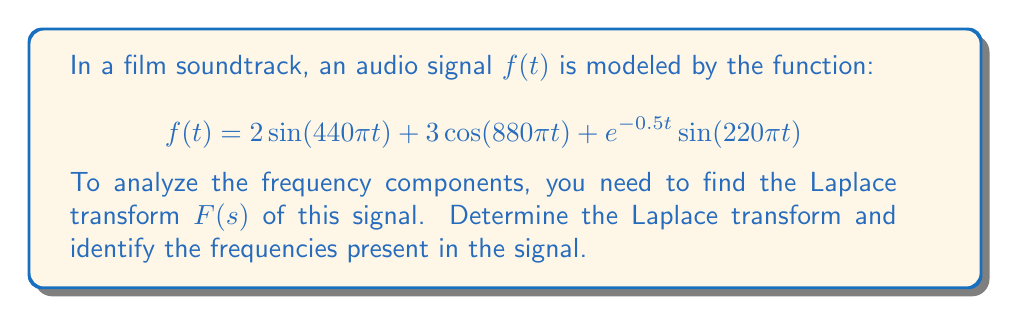Show me your answer to this math problem. To solve this problem, we'll use the Laplace transform properties and the linearity property to break down the function into simpler components.

1) First, recall the Laplace transforms of sine and cosine functions:
   $$\mathcal{L}\{\sin(\omega t)\} = \frac{\omega}{s^2 + \omega^2}$$
   $$\mathcal{L}\{\cos(\omega t)\} = \frac{s}{s^2 + \omega^2}$$

2) For the term $e^{-0.5t}\sin(220\pi t)$, we'll use the frequency shift property:
   $$\mathcal{L}\{e^{at}f(t)\} = F(s-a)$$

3) Now, let's transform each term:

   a) $2\sin(440\pi t)$:
      $$2 \cdot \frac{440\pi}{s^2 + (440\pi)^2} = \frac{880\pi}{s^2 + (440\pi)^2}$$

   b) $3\cos(880\pi t)$:
      $$3 \cdot \frac{s}{s^2 + (880\pi)^2} = \frac{3s}{s^2 + (880\pi)^2}$$

   c) $e^{-0.5t}\sin(220\pi t)$:
      $$\frac{220\pi}{(s+0.5)^2 + (220\pi)^2}$$

4) Using the linearity property of Laplace transforms, we sum these components:

   $$F(s) = \frac{880\pi}{s^2 + (440\pi)^2} + \frac{3s}{s^2 + (880\pi)^2} + \frac{220\pi}{(s+0.5)^2 + (220\pi)^2}$$

5) To identify the frequencies, we look at the denominators of each term:
   - $440\pi$ rad/s ≈ 220 Hz
   - $880\pi$ rad/s ≈ 440 Hz
   - $220\pi$ rad/s ≈ 110 Hz

These frequencies correspond to musical notes: A3 (220 Hz), A4 (440 Hz), and A2 (110 Hz).
Answer: The Laplace transform of the signal is:

$$F(s) = \frac{880\pi}{s^2 + (440\pi)^2} + \frac{3s}{s^2 + (880\pi)^2} + \frac{220\pi}{(s+0.5)^2 + (220\pi)^2}$$

The frequencies present in the signal are approximately 110 Hz, 220 Hz, and 440 Hz. 